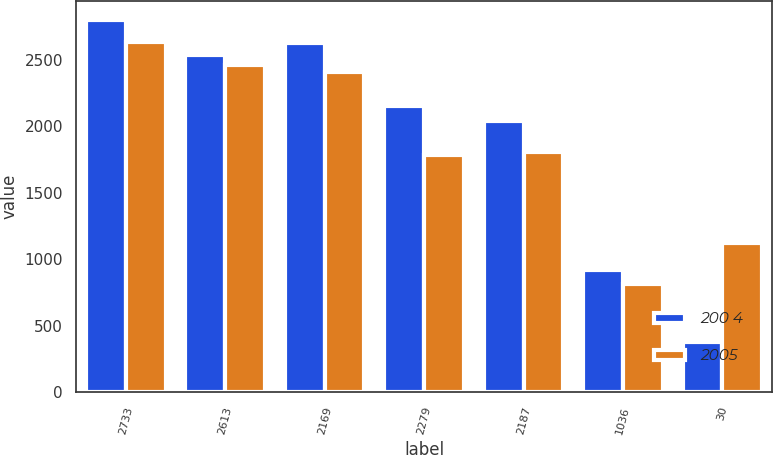Convert chart to OTSL. <chart><loc_0><loc_0><loc_500><loc_500><stacked_bar_chart><ecel><fcel>2733<fcel>2613<fcel>2169<fcel>2279<fcel>2187<fcel>1036<fcel>30<nl><fcel>200 4<fcel>2799<fcel>2535<fcel>2627<fcel>2154<fcel>2040<fcel>920<fcel>378<nl><fcel>2005<fcel>2631<fcel>2463<fcel>2410<fcel>1785<fcel>1809<fcel>816<fcel>1120<nl></chart> 